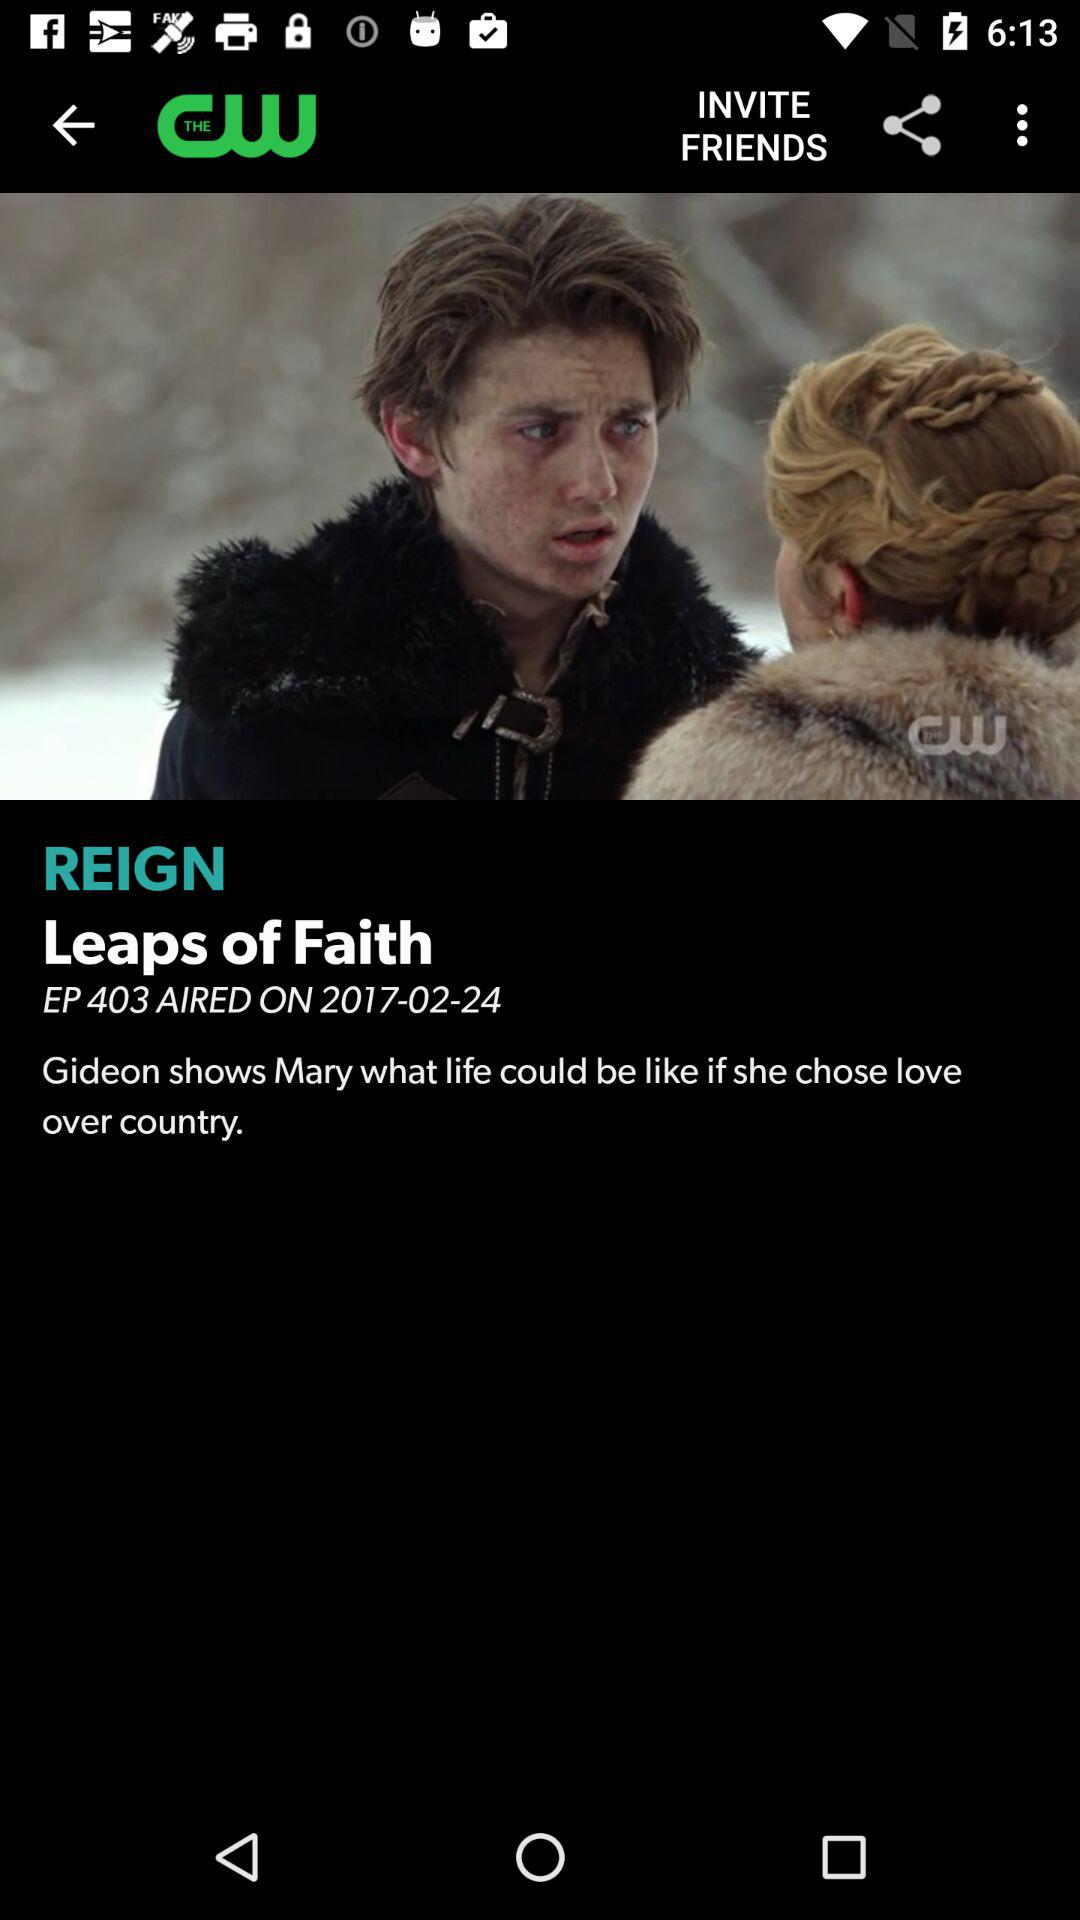What is the name of the drama? The name of the drama is "REGIN". 